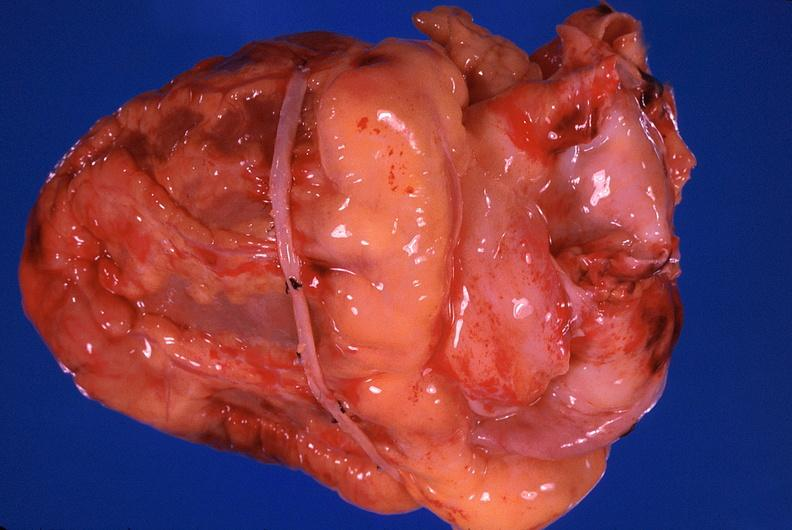what is present?
Answer the question using a single word or phrase. Cardiovascular 